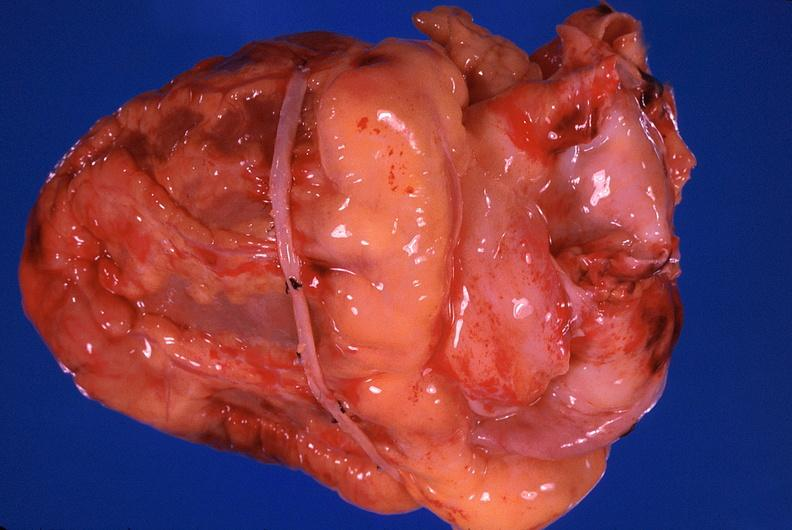what is present?
Answer the question using a single word or phrase. Cardiovascular 